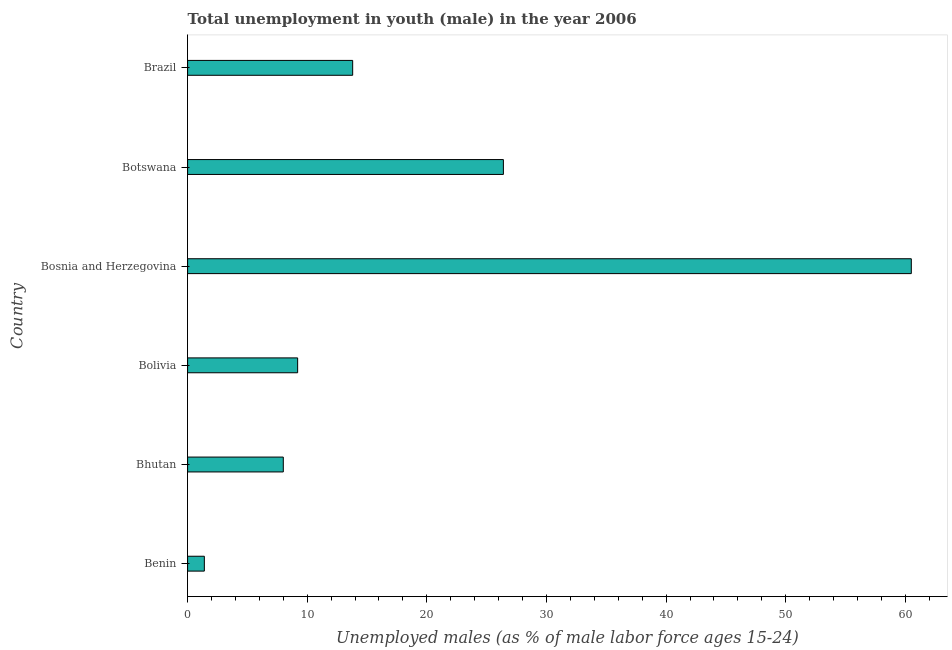Does the graph contain grids?
Offer a very short reply. No. What is the title of the graph?
Your response must be concise. Total unemployment in youth (male) in the year 2006. What is the label or title of the X-axis?
Keep it short and to the point. Unemployed males (as % of male labor force ages 15-24). What is the label or title of the Y-axis?
Offer a very short reply. Country. What is the unemployed male youth population in Brazil?
Your answer should be very brief. 13.8. Across all countries, what is the maximum unemployed male youth population?
Make the answer very short. 60.5. Across all countries, what is the minimum unemployed male youth population?
Your answer should be compact. 1.4. In which country was the unemployed male youth population maximum?
Your answer should be very brief. Bosnia and Herzegovina. In which country was the unemployed male youth population minimum?
Keep it short and to the point. Benin. What is the sum of the unemployed male youth population?
Provide a succinct answer. 119.3. What is the difference between the unemployed male youth population in Bosnia and Herzegovina and Botswana?
Provide a short and direct response. 34.1. What is the average unemployed male youth population per country?
Ensure brevity in your answer.  19.88. What is the median unemployed male youth population?
Provide a short and direct response. 11.5. In how many countries, is the unemployed male youth population greater than 10 %?
Give a very brief answer. 3. What is the ratio of the unemployed male youth population in Bosnia and Herzegovina to that in Botswana?
Your response must be concise. 2.29. What is the difference between the highest and the second highest unemployed male youth population?
Offer a very short reply. 34.1. Is the sum of the unemployed male youth population in Bolivia and Bosnia and Herzegovina greater than the maximum unemployed male youth population across all countries?
Provide a short and direct response. Yes. What is the difference between the highest and the lowest unemployed male youth population?
Your response must be concise. 59.1. In how many countries, is the unemployed male youth population greater than the average unemployed male youth population taken over all countries?
Your answer should be very brief. 2. How many bars are there?
Give a very brief answer. 6. What is the difference between two consecutive major ticks on the X-axis?
Make the answer very short. 10. What is the Unemployed males (as % of male labor force ages 15-24) in Benin?
Your response must be concise. 1.4. What is the Unemployed males (as % of male labor force ages 15-24) in Bolivia?
Your answer should be very brief. 9.2. What is the Unemployed males (as % of male labor force ages 15-24) of Bosnia and Herzegovina?
Offer a very short reply. 60.5. What is the Unemployed males (as % of male labor force ages 15-24) of Botswana?
Provide a short and direct response. 26.4. What is the Unemployed males (as % of male labor force ages 15-24) in Brazil?
Your answer should be compact. 13.8. What is the difference between the Unemployed males (as % of male labor force ages 15-24) in Benin and Bolivia?
Your answer should be compact. -7.8. What is the difference between the Unemployed males (as % of male labor force ages 15-24) in Benin and Bosnia and Herzegovina?
Your answer should be compact. -59.1. What is the difference between the Unemployed males (as % of male labor force ages 15-24) in Benin and Botswana?
Your answer should be very brief. -25. What is the difference between the Unemployed males (as % of male labor force ages 15-24) in Bhutan and Bosnia and Herzegovina?
Your answer should be very brief. -52.5. What is the difference between the Unemployed males (as % of male labor force ages 15-24) in Bhutan and Botswana?
Your answer should be very brief. -18.4. What is the difference between the Unemployed males (as % of male labor force ages 15-24) in Bolivia and Bosnia and Herzegovina?
Give a very brief answer. -51.3. What is the difference between the Unemployed males (as % of male labor force ages 15-24) in Bolivia and Botswana?
Offer a terse response. -17.2. What is the difference between the Unemployed males (as % of male labor force ages 15-24) in Bosnia and Herzegovina and Botswana?
Your answer should be compact. 34.1. What is the difference between the Unemployed males (as % of male labor force ages 15-24) in Bosnia and Herzegovina and Brazil?
Offer a terse response. 46.7. What is the difference between the Unemployed males (as % of male labor force ages 15-24) in Botswana and Brazil?
Offer a terse response. 12.6. What is the ratio of the Unemployed males (as % of male labor force ages 15-24) in Benin to that in Bhutan?
Make the answer very short. 0.17. What is the ratio of the Unemployed males (as % of male labor force ages 15-24) in Benin to that in Bolivia?
Provide a short and direct response. 0.15. What is the ratio of the Unemployed males (as % of male labor force ages 15-24) in Benin to that in Bosnia and Herzegovina?
Make the answer very short. 0.02. What is the ratio of the Unemployed males (as % of male labor force ages 15-24) in Benin to that in Botswana?
Provide a succinct answer. 0.05. What is the ratio of the Unemployed males (as % of male labor force ages 15-24) in Benin to that in Brazil?
Keep it short and to the point. 0.1. What is the ratio of the Unemployed males (as % of male labor force ages 15-24) in Bhutan to that in Bolivia?
Your answer should be very brief. 0.87. What is the ratio of the Unemployed males (as % of male labor force ages 15-24) in Bhutan to that in Bosnia and Herzegovina?
Provide a short and direct response. 0.13. What is the ratio of the Unemployed males (as % of male labor force ages 15-24) in Bhutan to that in Botswana?
Give a very brief answer. 0.3. What is the ratio of the Unemployed males (as % of male labor force ages 15-24) in Bhutan to that in Brazil?
Your answer should be very brief. 0.58. What is the ratio of the Unemployed males (as % of male labor force ages 15-24) in Bolivia to that in Bosnia and Herzegovina?
Offer a terse response. 0.15. What is the ratio of the Unemployed males (as % of male labor force ages 15-24) in Bolivia to that in Botswana?
Your answer should be very brief. 0.35. What is the ratio of the Unemployed males (as % of male labor force ages 15-24) in Bolivia to that in Brazil?
Keep it short and to the point. 0.67. What is the ratio of the Unemployed males (as % of male labor force ages 15-24) in Bosnia and Herzegovina to that in Botswana?
Your answer should be compact. 2.29. What is the ratio of the Unemployed males (as % of male labor force ages 15-24) in Bosnia and Herzegovina to that in Brazil?
Keep it short and to the point. 4.38. What is the ratio of the Unemployed males (as % of male labor force ages 15-24) in Botswana to that in Brazil?
Offer a very short reply. 1.91. 